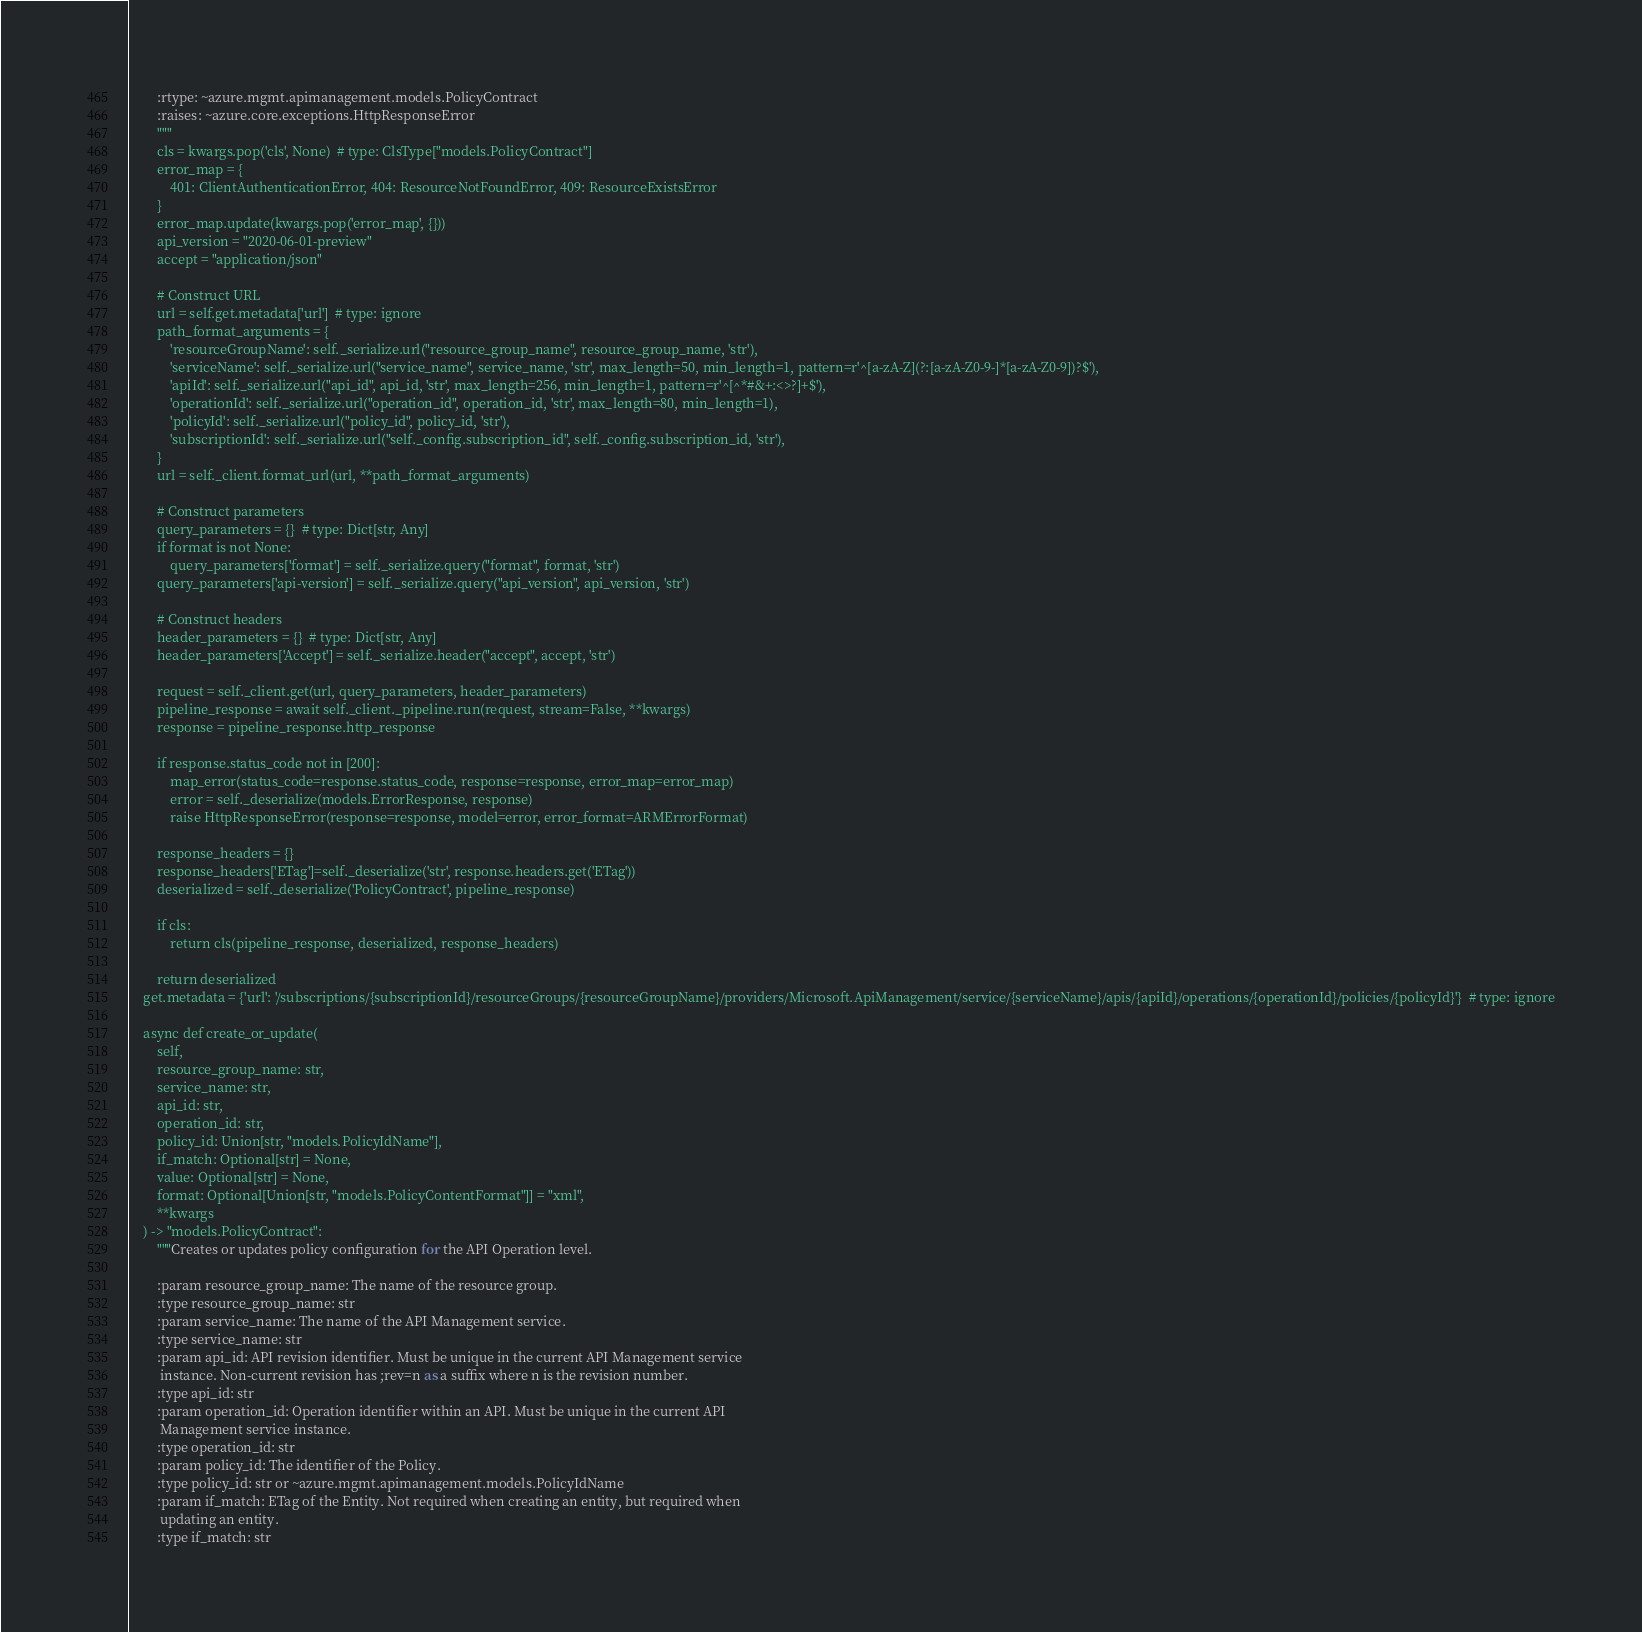<code> <loc_0><loc_0><loc_500><loc_500><_Python_>        :rtype: ~azure.mgmt.apimanagement.models.PolicyContract
        :raises: ~azure.core.exceptions.HttpResponseError
        """
        cls = kwargs.pop('cls', None)  # type: ClsType["models.PolicyContract"]
        error_map = {
            401: ClientAuthenticationError, 404: ResourceNotFoundError, 409: ResourceExistsError
        }
        error_map.update(kwargs.pop('error_map', {}))
        api_version = "2020-06-01-preview"
        accept = "application/json"

        # Construct URL
        url = self.get.metadata['url']  # type: ignore
        path_format_arguments = {
            'resourceGroupName': self._serialize.url("resource_group_name", resource_group_name, 'str'),
            'serviceName': self._serialize.url("service_name", service_name, 'str', max_length=50, min_length=1, pattern=r'^[a-zA-Z](?:[a-zA-Z0-9-]*[a-zA-Z0-9])?$'),
            'apiId': self._serialize.url("api_id", api_id, 'str', max_length=256, min_length=1, pattern=r'^[^*#&+:<>?]+$'),
            'operationId': self._serialize.url("operation_id", operation_id, 'str', max_length=80, min_length=1),
            'policyId': self._serialize.url("policy_id", policy_id, 'str'),
            'subscriptionId': self._serialize.url("self._config.subscription_id", self._config.subscription_id, 'str'),
        }
        url = self._client.format_url(url, **path_format_arguments)

        # Construct parameters
        query_parameters = {}  # type: Dict[str, Any]
        if format is not None:
            query_parameters['format'] = self._serialize.query("format", format, 'str')
        query_parameters['api-version'] = self._serialize.query("api_version", api_version, 'str')

        # Construct headers
        header_parameters = {}  # type: Dict[str, Any]
        header_parameters['Accept'] = self._serialize.header("accept", accept, 'str')

        request = self._client.get(url, query_parameters, header_parameters)
        pipeline_response = await self._client._pipeline.run(request, stream=False, **kwargs)
        response = pipeline_response.http_response

        if response.status_code not in [200]:
            map_error(status_code=response.status_code, response=response, error_map=error_map)
            error = self._deserialize(models.ErrorResponse, response)
            raise HttpResponseError(response=response, model=error, error_format=ARMErrorFormat)

        response_headers = {}
        response_headers['ETag']=self._deserialize('str', response.headers.get('ETag'))
        deserialized = self._deserialize('PolicyContract', pipeline_response)

        if cls:
            return cls(pipeline_response, deserialized, response_headers)

        return deserialized
    get.metadata = {'url': '/subscriptions/{subscriptionId}/resourceGroups/{resourceGroupName}/providers/Microsoft.ApiManagement/service/{serviceName}/apis/{apiId}/operations/{operationId}/policies/{policyId}'}  # type: ignore

    async def create_or_update(
        self,
        resource_group_name: str,
        service_name: str,
        api_id: str,
        operation_id: str,
        policy_id: Union[str, "models.PolicyIdName"],
        if_match: Optional[str] = None,
        value: Optional[str] = None,
        format: Optional[Union[str, "models.PolicyContentFormat"]] = "xml",
        **kwargs
    ) -> "models.PolicyContract":
        """Creates or updates policy configuration for the API Operation level.

        :param resource_group_name: The name of the resource group.
        :type resource_group_name: str
        :param service_name: The name of the API Management service.
        :type service_name: str
        :param api_id: API revision identifier. Must be unique in the current API Management service
         instance. Non-current revision has ;rev=n as a suffix where n is the revision number.
        :type api_id: str
        :param operation_id: Operation identifier within an API. Must be unique in the current API
         Management service instance.
        :type operation_id: str
        :param policy_id: The identifier of the Policy.
        :type policy_id: str or ~azure.mgmt.apimanagement.models.PolicyIdName
        :param if_match: ETag of the Entity. Not required when creating an entity, but required when
         updating an entity.
        :type if_match: str</code> 